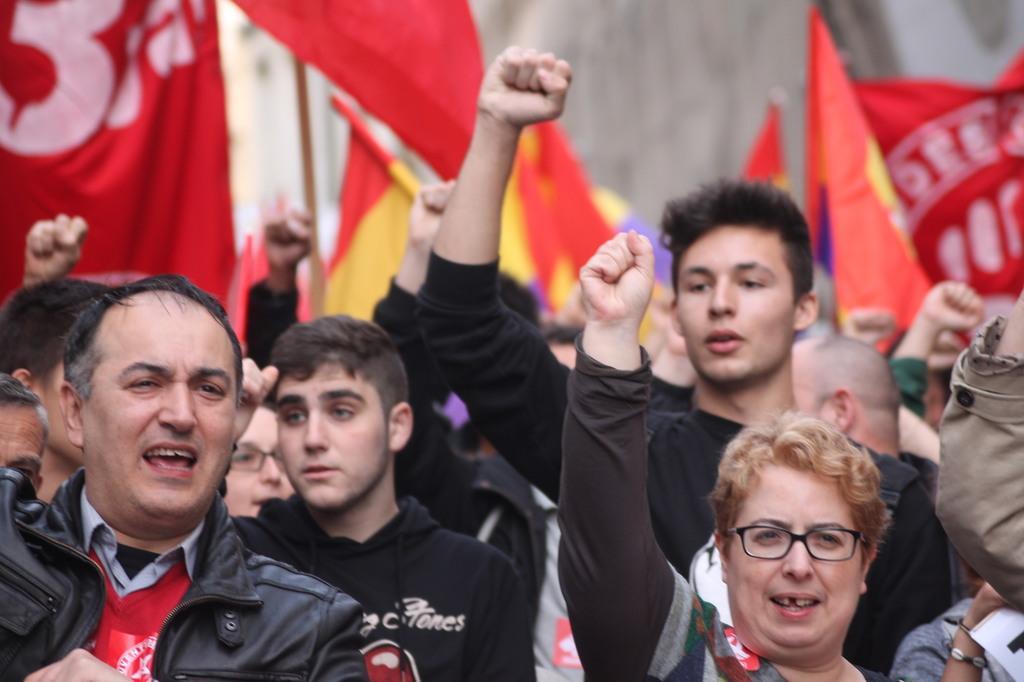Describe this image in one or two sentences. In this picture there are group of people raising their hands and shouting. At the back there are red color flags. 